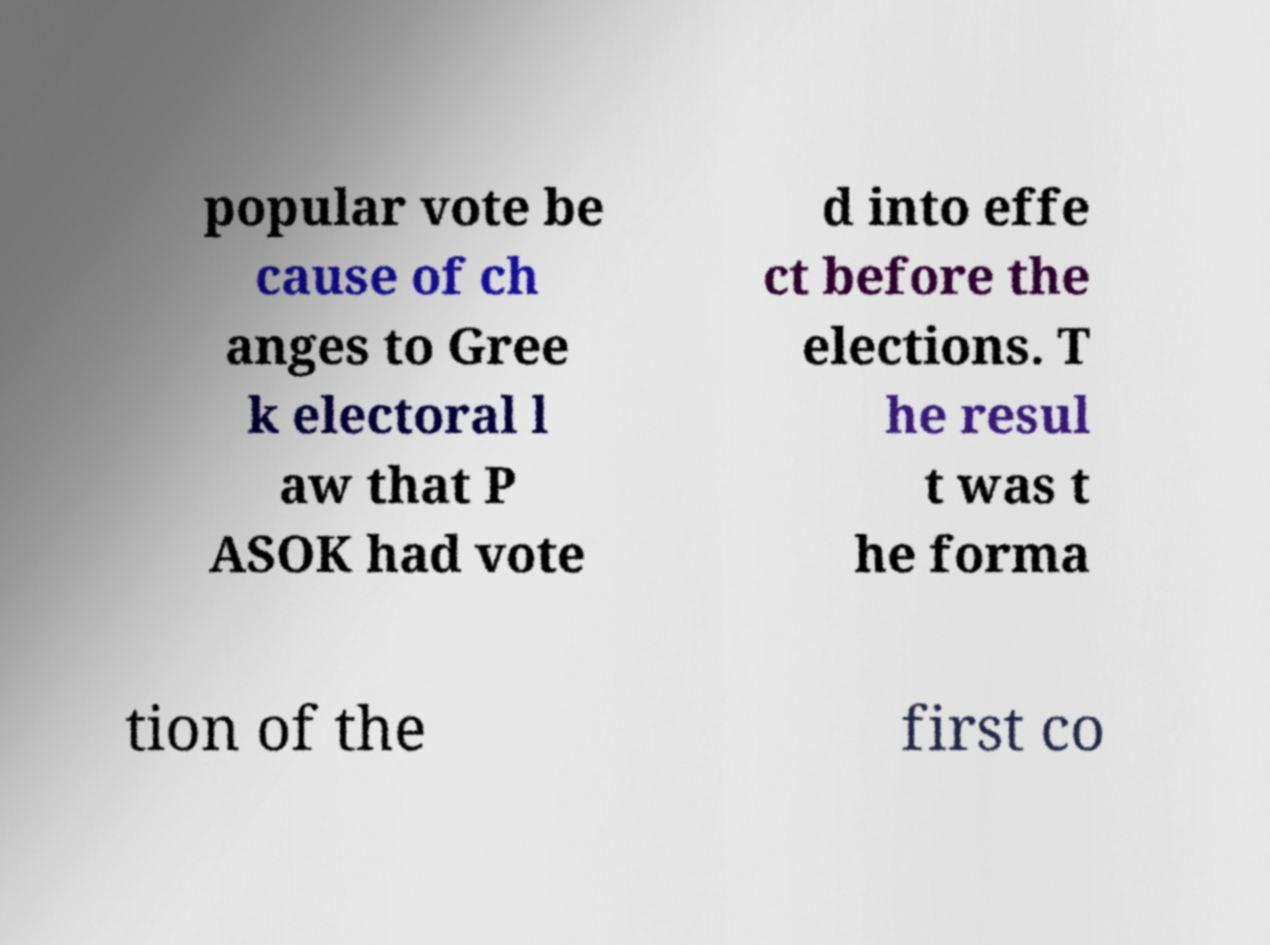Please identify and transcribe the text found in this image. popular vote be cause of ch anges to Gree k electoral l aw that P ASOK had vote d into effe ct before the elections. T he resul t was t he forma tion of the first co 